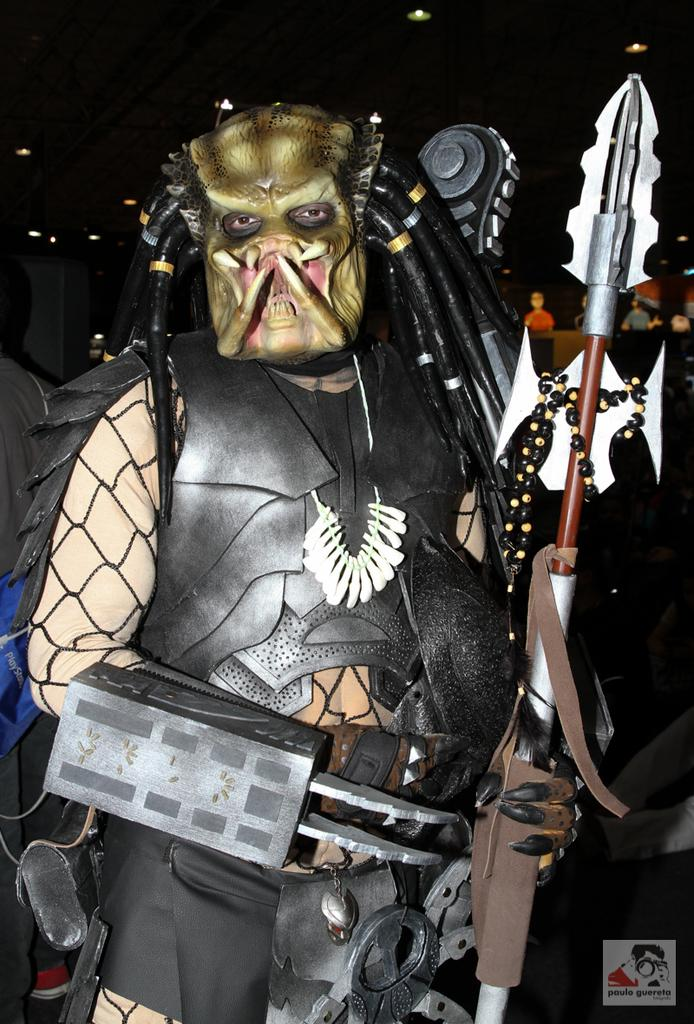What is present in the image? There is a person in the image. What is the person wearing? The person is wearing a different costume. What is the person holding in their hands? The person is holding something in their hands. What type of key can be seen hanging from the person's vest in the image? There is no key or vest present in the image. 